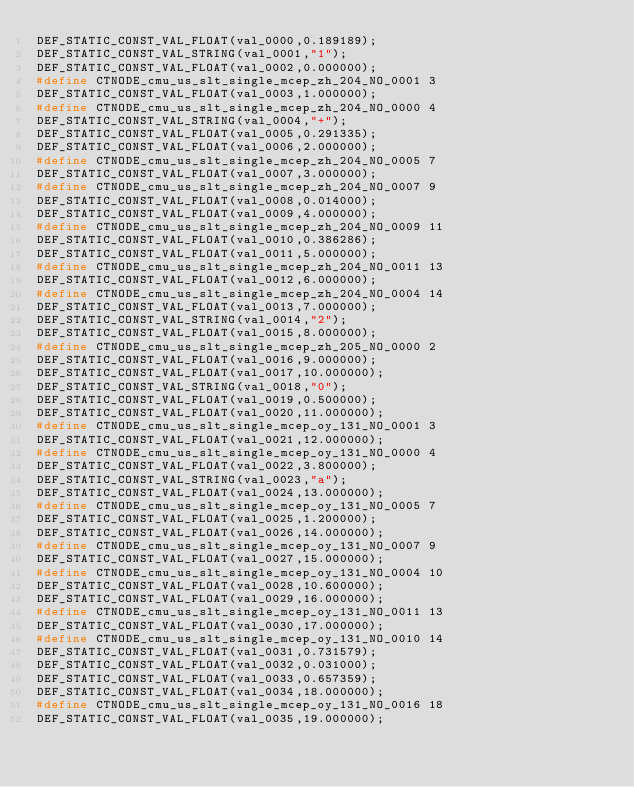<code> <loc_0><loc_0><loc_500><loc_500><_C_>DEF_STATIC_CONST_VAL_FLOAT(val_0000,0.189189);
DEF_STATIC_CONST_VAL_STRING(val_0001,"1");
DEF_STATIC_CONST_VAL_FLOAT(val_0002,0.000000);
#define CTNODE_cmu_us_slt_single_mcep_zh_204_NO_0001 3
DEF_STATIC_CONST_VAL_FLOAT(val_0003,1.000000);
#define CTNODE_cmu_us_slt_single_mcep_zh_204_NO_0000 4
DEF_STATIC_CONST_VAL_STRING(val_0004,"+");
DEF_STATIC_CONST_VAL_FLOAT(val_0005,0.291335);
DEF_STATIC_CONST_VAL_FLOAT(val_0006,2.000000);
#define CTNODE_cmu_us_slt_single_mcep_zh_204_NO_0005 7
DEF_STATIC_CONST_VAL_FLOAT(val_0007,3.000000);
#define CTNODE_cmu_us_slt_single_mcep_zh_204_NO_0007 9
DEF_STATIC_CONST_VAL_FLOAT(val_0008,0.014000);
DEF_STATIC_CONST_VAL_FLOAT(val_0009,4.000000);
#define CTNODE_cmu_us_slt_single_mcep_zh_204_NO_0009 11
DEF_STATIC_CONST_VAL_FLOAT(val_0010,0.386286);
DEF_STATIC_CONST_VAL_FLOAT(val_0011,5.000000);
#define CTNODE_cmu_us_slt_single_mcep_zh_204_NO_0011 13
DEF_STATIC_CONST_VAL_FLOAT(val_0012,6.000000);
#define CTNODE_cmu_us_slt_single_mcep_zh_204_NO_0004 14
DEF_STATIC_CONST_VAL_FLOAT(val_0013,7.000000);
DEF_STATIC_CONST_VAL_STRING(val_0014,"2");
DEF_STATIC_CONST_VAL_FLOAT(val_0015,8.000000);
#define CTNODE_cmu_us_slt_single_mcep_zh_205_NO_0000 2
DEF_STATIC_CONST_VAL_FLOAT(val_0016,9.000000);
DEF_STATIC_CONST_VAL_FLOAT(val_0017,10.000000);
DEF_STATIC_CONST_VAL_STRING(val_0018,"0");
DEF_STATIC_CONST_VAL_FLOAT(val_0019,0.500000);
DEF_STATIC_CONST_VAL_FLOAT(val_0020,11.000000);
#define CTNODE_cmu_us_slt_single_mcep_oy_131_NO_0001 3
DEF_STATIC_CONST_VAL_FLOAT(val_0021,12.000000);
#define CTNODE_cmu_us_slt_single_mcep_oy_131_NO_0000 4
DEF_STATIC_CONST_VAL_FLOAT(val_0022,3.800000);
DEF_STATIC_CONST_VAL_STRING(val_0023,"a");
DEF_STATIC_CONST_VAL_FLOAT(val_0024,13.000000);
#define CTNODE_cmu_us_slt_single_mcep_oy_131_NO_0005 7
DEF_STATIC_CONST_VAL_FLOAT(val_0025,1.200000);
DEF_STATIC_CONST_VAL_FLOAT(val_0026,14.000000);
#define CTNODE_cmu_us_slt_single_mcep_oy_131_NO_0007 9
DEF_STATIC_CONST_VAL_FLOAT(val_0027,15.000000);
#define CTNODE_cmu_us_slt_single_mcep_oy_131_NO_0004 10
DEF_STATIC_CONST_VAL_FLOAT(val_0028,10.600000);
DEF_STATIC_CONST_VAL_FLOAT(val_0029,16.000000);
#define CTNODE_cmu_us_slt_single_mcep_oy_131_NO_0011 13
DEF_STATIC_CONST_VAL_FLOAT(val_0030,17.000000);
#define CTNODE_cmu_us_slt_single_mcep_oy_131_NO_0010 14
DEF_STATIC_CONST_VAL_FLOAT(val_0031,0.731579);
DEF_STATIC_CONST_VAL_FLOAT(val_0032,0.031000);
DEF_STATIC_CONST_VAL_FLOAT(val_0033,0.657359);
DEF_STATIC_CONST_VAL_FLOAT(val_0034,18.000000);
#define CTNODE_cmu_us_slt_single_mcep_oy_131_NO_0016 18
DEF_STATIC_CONST_VAL_FLOAT(val_0035,19.000000);</code> 